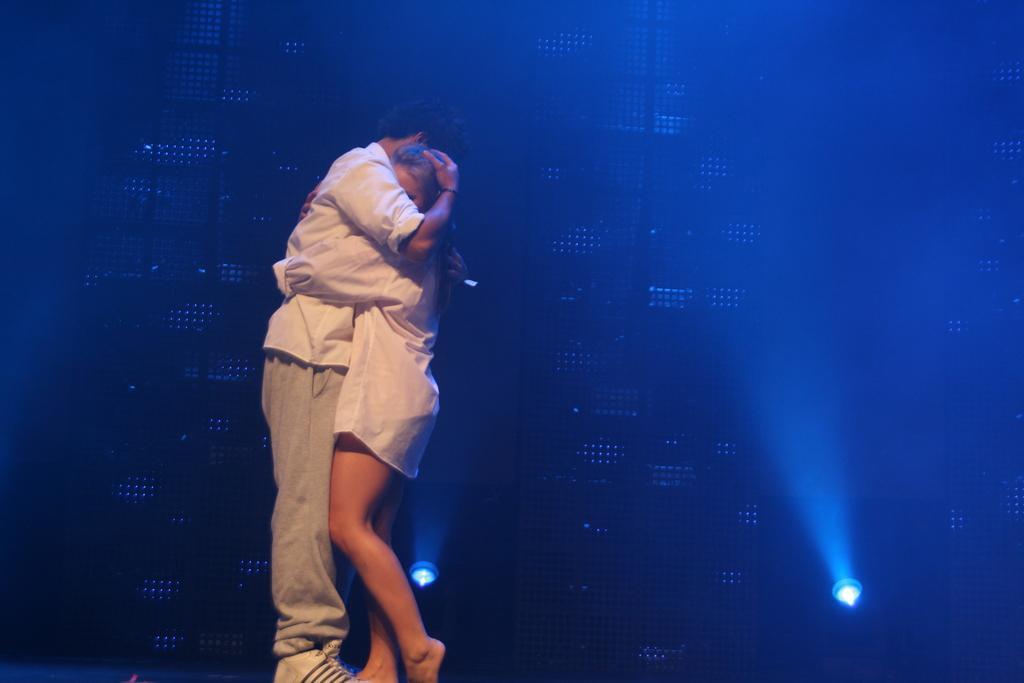Please provide a concise description of this image. In this image a person and a woman are hugging each other. They are standing. They are wearing white shirts. Behind them there are two lights on the floor. 